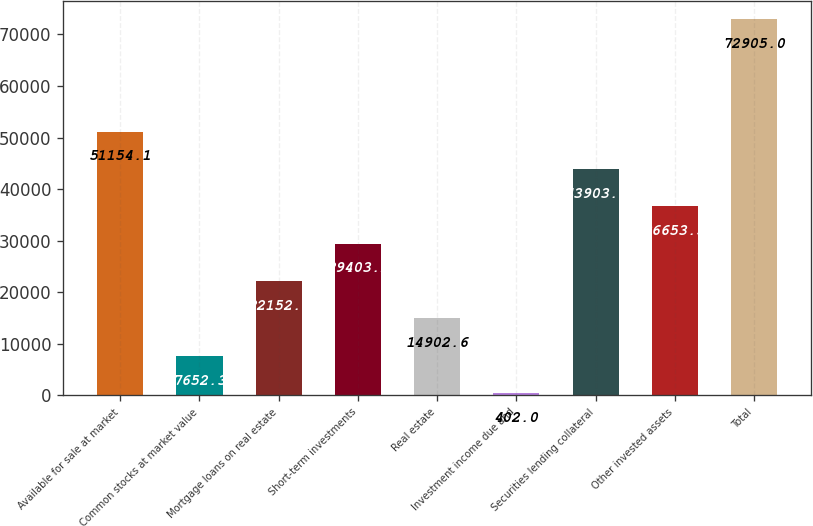<chart> <loc_0><loc_0><loc_500><loc_500><bar_chart><fcel>Available for sale at market<fcel>Common stocks at market value<fcel>Mortgage loans on real estate<fcel>Short-term investments<fcel>Real estate<fcel>Investment income due and<fcel>Securities lending collateral<fcel>Other invested assets<fcel>Total<nl><fcel>51154.1<fcel>7652.3<fcel>22152.9<fcel>29403.2<fcel>14902.6<fcel>402<fcel>43903.8<fcel>36653.5<fcel>72905<nl></chart> 